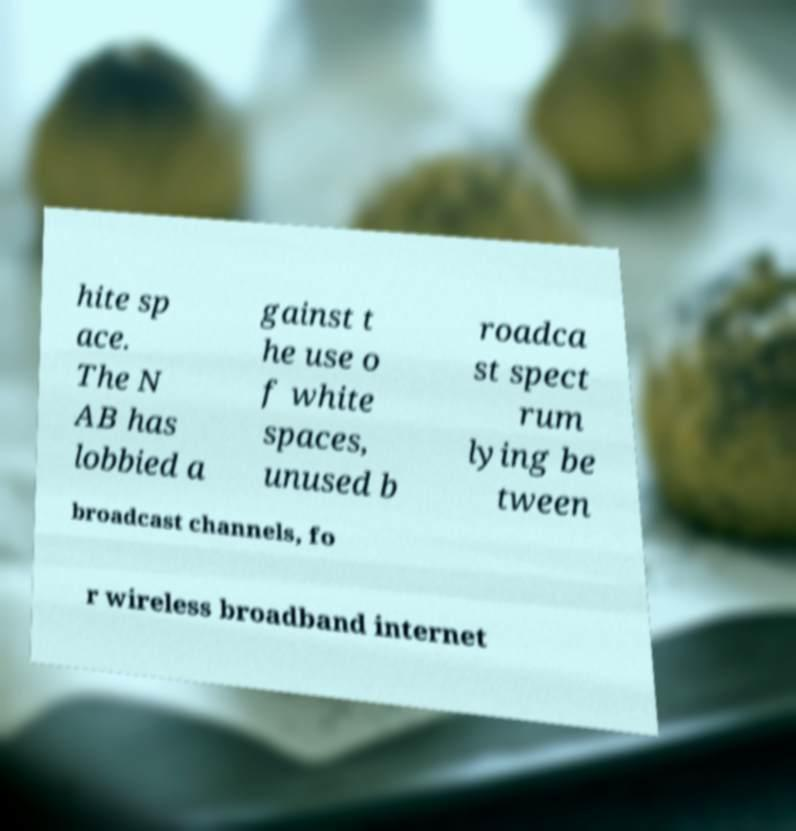Can you accurately transcribe the text from the provided image for me? hite sp ace. The N AB has lobbied a gainst t he use o f white spaces, unused b roadca st spect rum lying be tween broadcast channels, fo r wireless broadband internet 